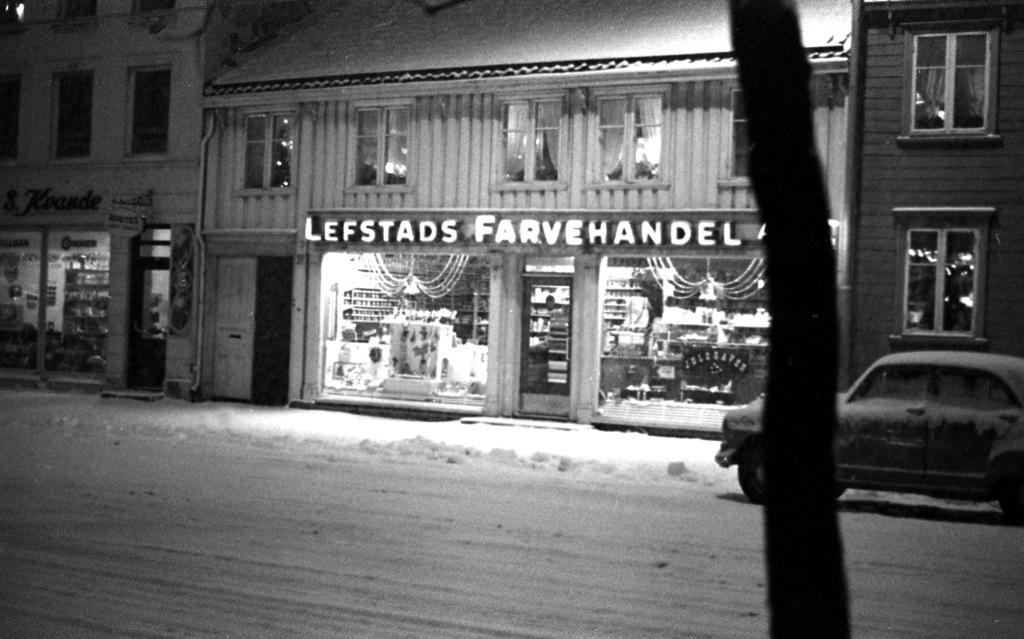What is the main object in the foreground of the image? There is a tree trunk in the image. What is located on the surface in the image? There is a car on the surface in the image. What can be seen in the background of the image? There are buildings, windows, and a door in the background of the image. What type of news can be heard coming from the tree trunk in the image? There is no news or sound coming from the tree trunk in the image. 